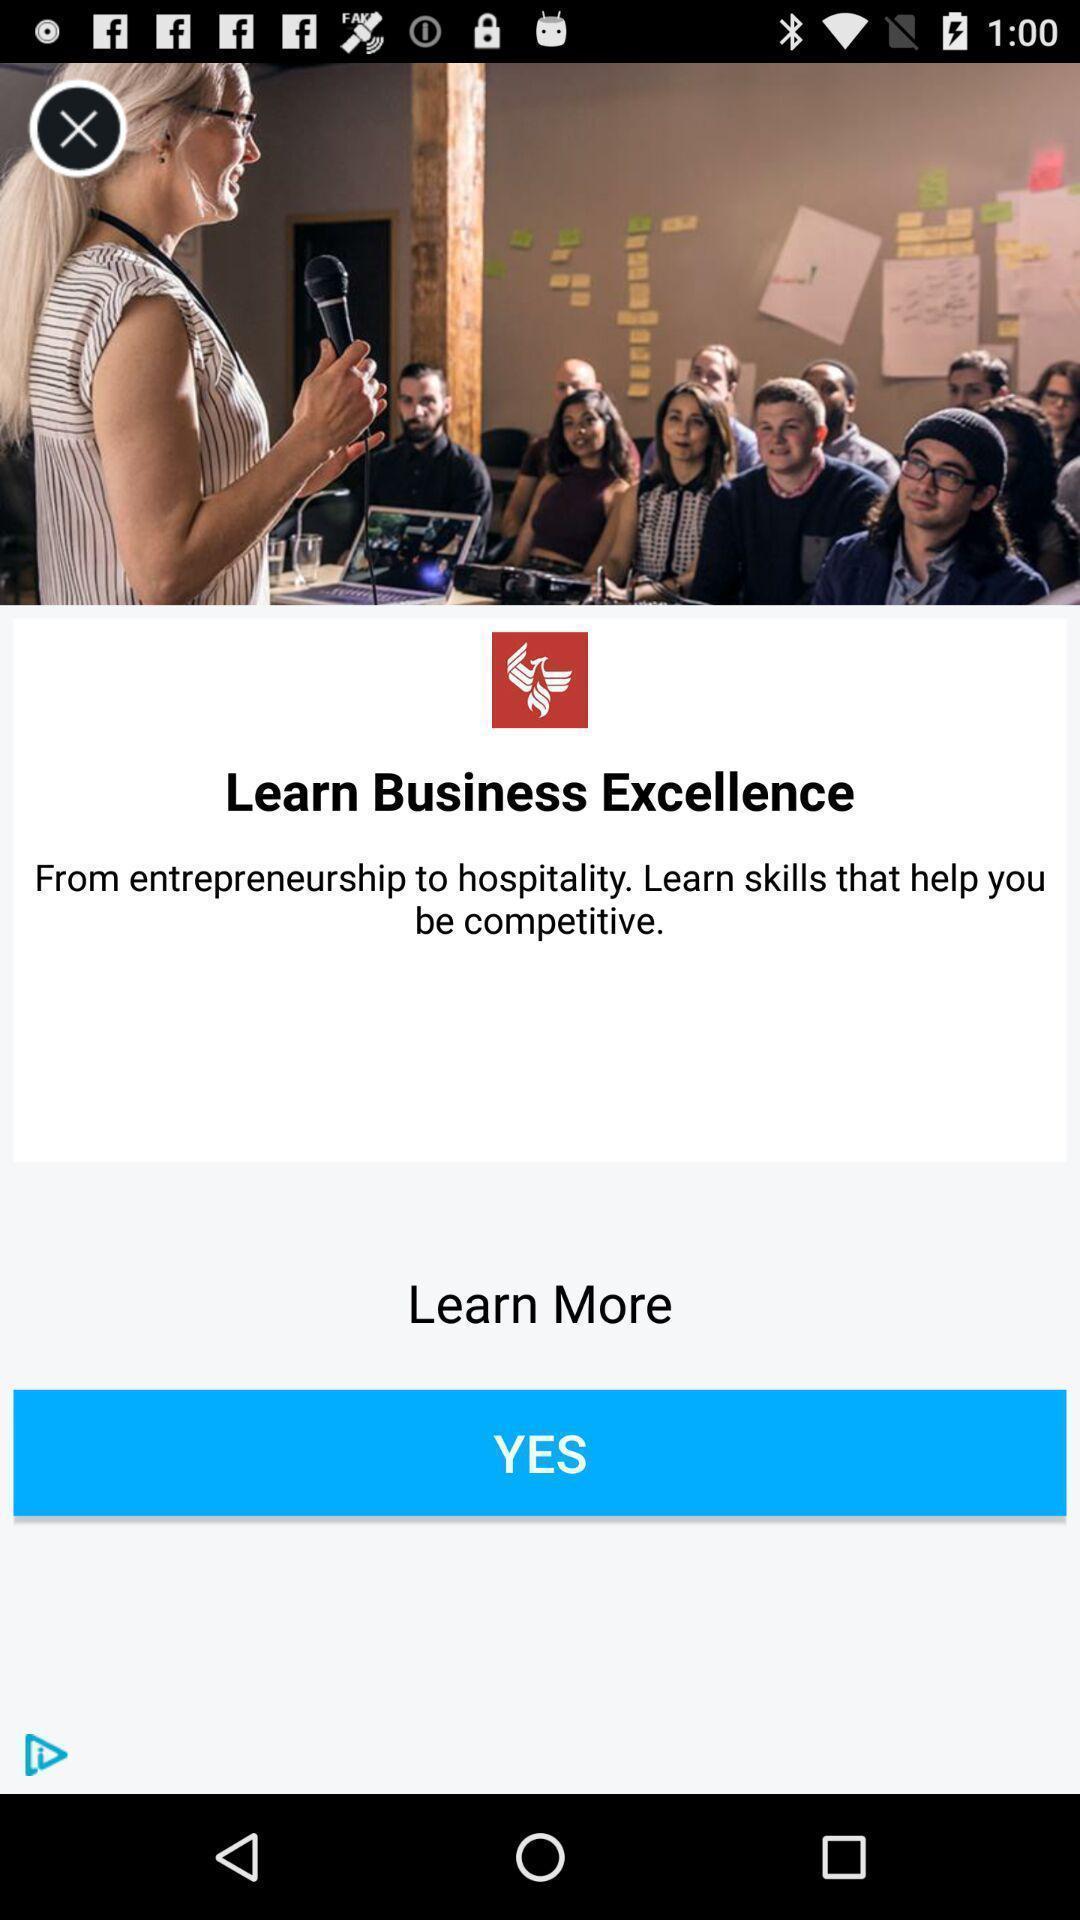Explain what's happening in this screen capture. Page showing option like yes. 